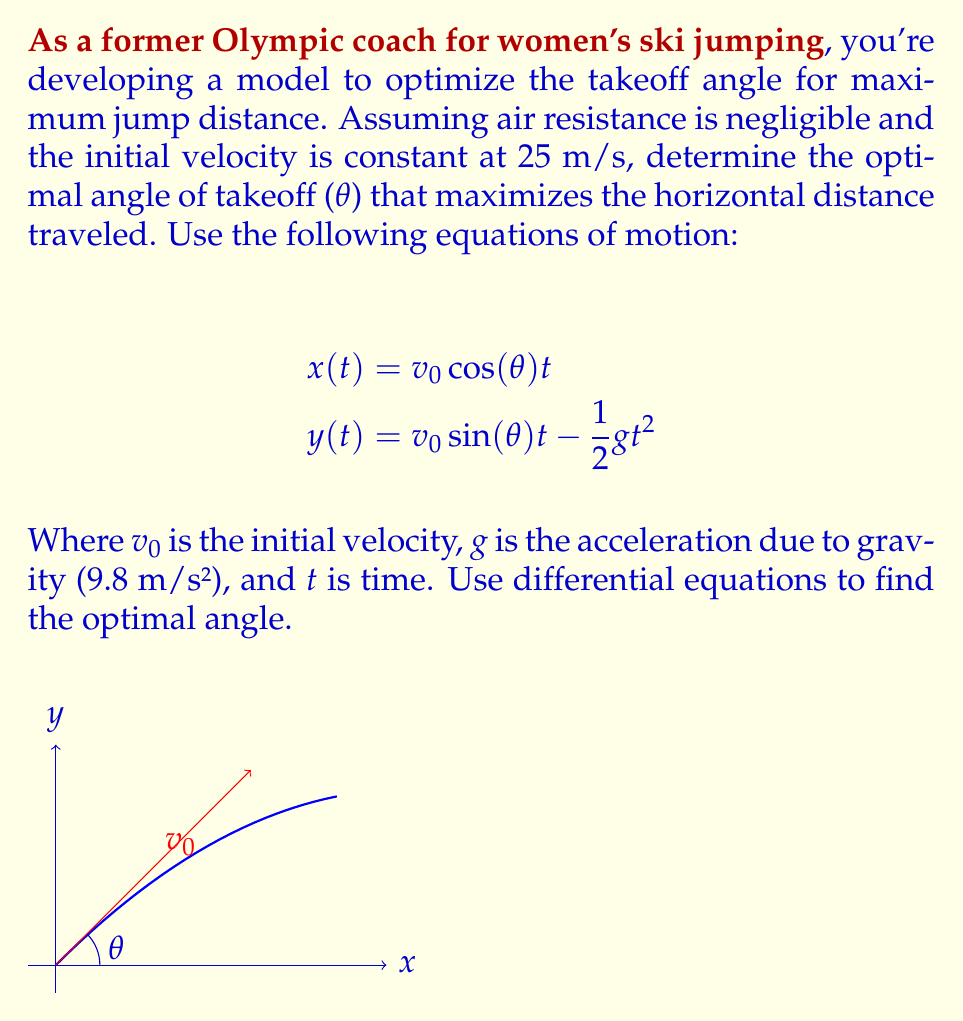What is the answer to this math problem? To find the optimal angle of takeoff, we need to maximize the horizontal distance traveled. Let's approach this step-by-step:

1) First, we need to find the time when the jumper lands (y = 0). From the vertical motion equation:

   $$0 = v_0 \sin(\theta) t - \frac{1}{2}gt^2$$

2) Solving this quadratic equation for t:

   $$t = \frac{2v_0 \sin(\theta)}{g}$$

3) Now, we substitute this time into the horizontal distance equation:

   $$x = v_0 \cos(\theta) \cdot \frac{2v_0 \sin(\theta)}{g} = \frac{2v_0^2 \sin(\theta) \cos(\theta)}{g}$$

4) Using the trigonometric identity $\sin(2\theta) = 2\sin(\theta)\cos(\theta)$, we can simplify:

   $$x = \frac{v_0^2 \sin(2\theta)}{g}$$

5) To find the maximum, we differentiate x with respect to θ and set it to zero:

   $$\frac{dx}{d\theta} = \frac{v_0^2 \cos(2\theta)}{g} = 0$$

6) This is satisfied when $\cos(2\theta) = 0$, which occurs when $2\theta = 90°$ or $\theta = 45°$.

7) To confirm this is a maximum, we can check the second derivative is negative at this point.

Therefore, the optimal angle of takeoff for maximum distance is 45°.
Answer: 45° 